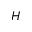<formula> <loc_0><loc_0><loc_500><loc_500>H</formula> 